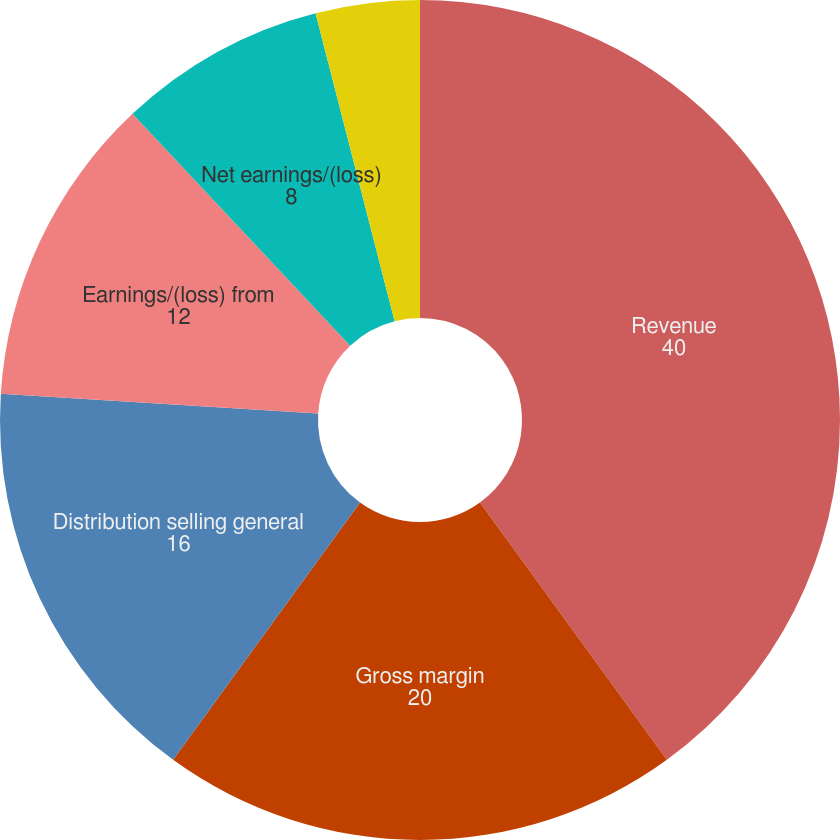Convert chart. <chart><loc_0><loc_0><loc_500><loc_500><pie_chart><fcel>Revenue<fcel>Gross margin<fcel>Distribution selling general<fcel>Earnings/(loss) from<fcel>Net earnings/(loss)<fcel>Basic<fcel>Diluted (3)<nl><fcel>40.0%<fcel>20.0%<fcel>16.0%<fcel>12.0%<fcel>8.0%<fcel>4.0%<fcel>0.0%<nl></chart> 